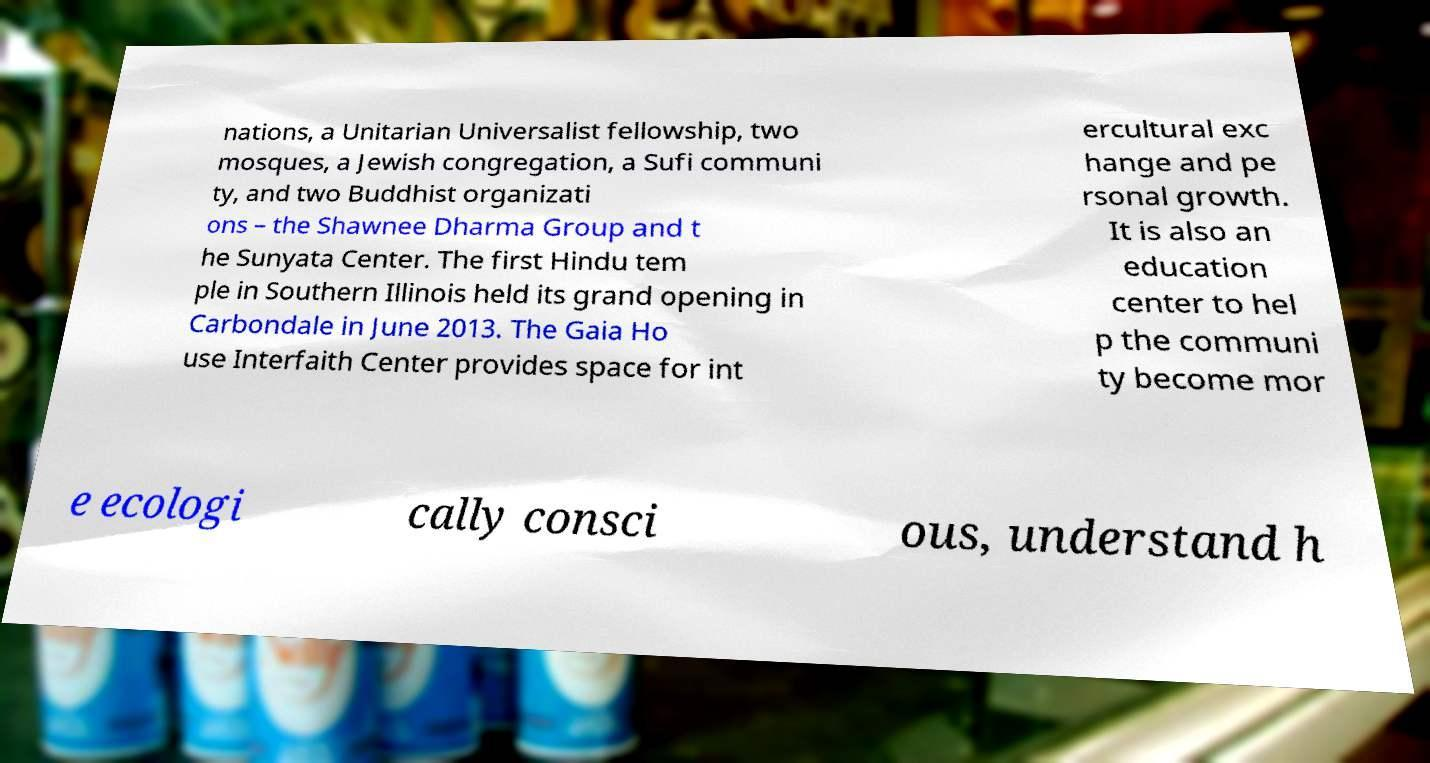Could you assist in decoding the text presented in this image and type it out clearly? nations, a Unitarian Universalist fellowship, two mosques, a Jewish congregation, a Sufi communi ty, and two Buddhist organizati ons – the Shawnee Dharma Group and t he Sunyata Center. The first Hindu tem ple in Southern Illinois held its grand opening in Carbondale in June 2013. The Gaia Ho use Interfaith Center provides space for int ercultural exc hange and pe rsonal growth. It is also an education center to hel p the communi ty become mor e ecologi cally consci ous, understand h 